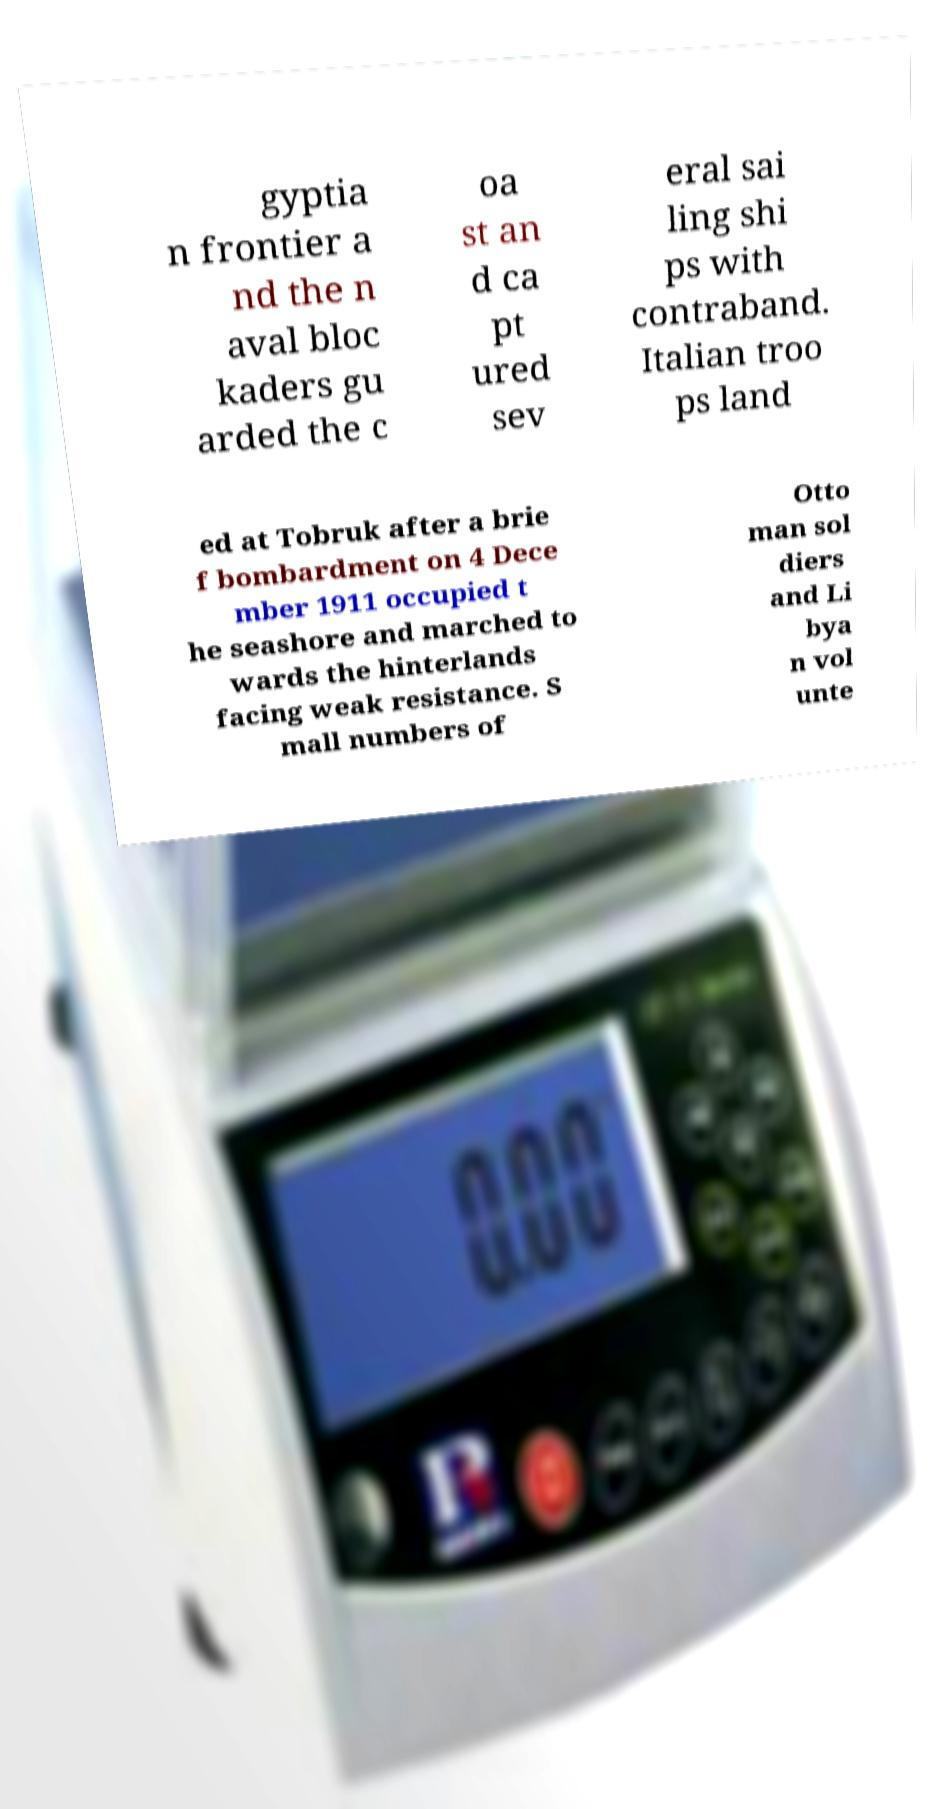I need the written content from this picture converted into text. Can you do that? gyptia n frontier a nd the n aval bloc kaders gu arded the c oa st an d ca pt ured sev eral sai ling shi ps with contraband. Italian troo ps land ed at Tobruk after a brie f bombardment on 4 Dece mber 1911 occupied t he seashore and marched to wards the hinterlands facing weak resistance. S mall numbers of Otto man sol diers and Li bya n vol unte 